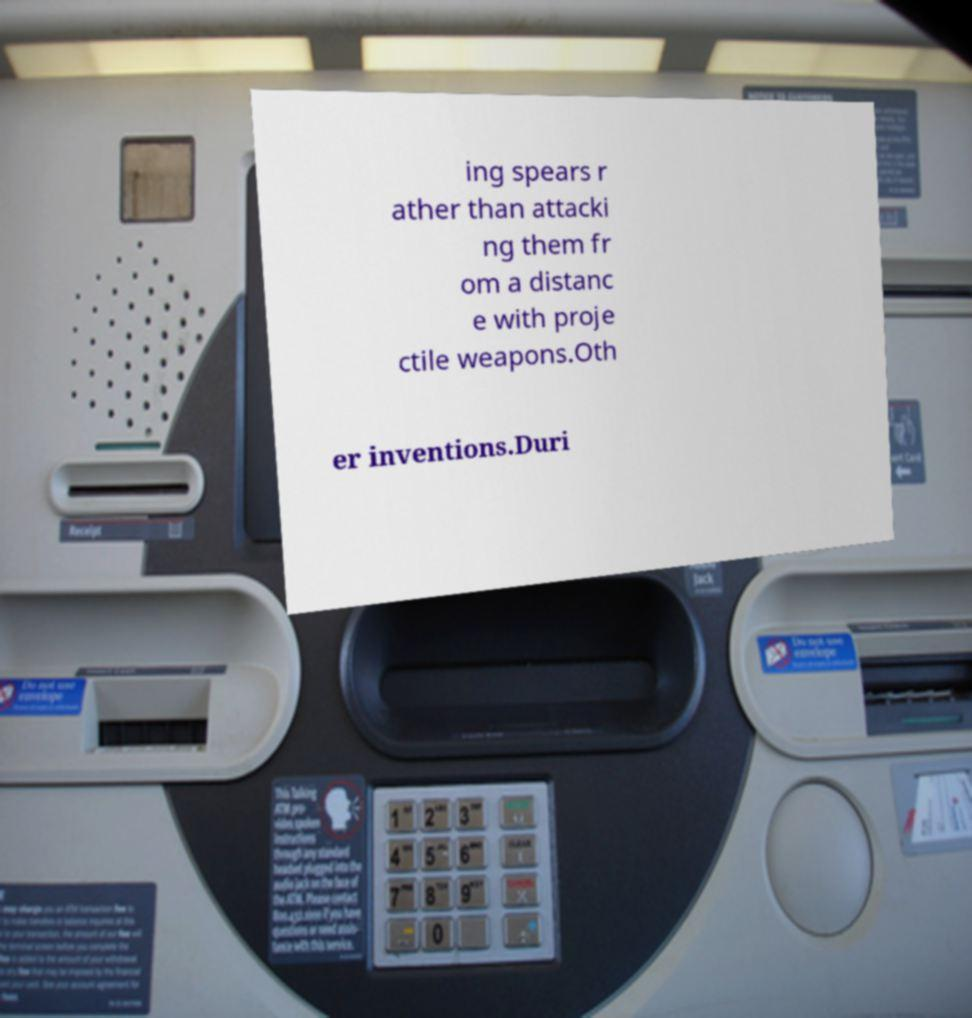Could you assist in decoding the text presented in this image and type it out clearly? ing spears r ather than attacki ng them fr om a distanc e with proje ctile weapons.Oth er inventions.Duri 